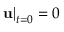<formula> <loc_0><loc_0><loc_500><loc_500>{ { u } \right | _ { t = 0 } } = 0</formula> 